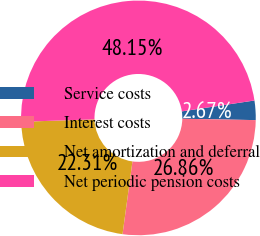Convert chart to OTSL. <chart><loc_0><loc_0><loc_500><loc_500><pie_chart><fcel>Service costs<fcel>Interest costs<fcel>Net amortization and deferral<fcel>Net periodic pension costs<nl><fcel>2.67%<fcel>26.86%<fcel>22.31%<fcel>48.15%<nl></chart> 